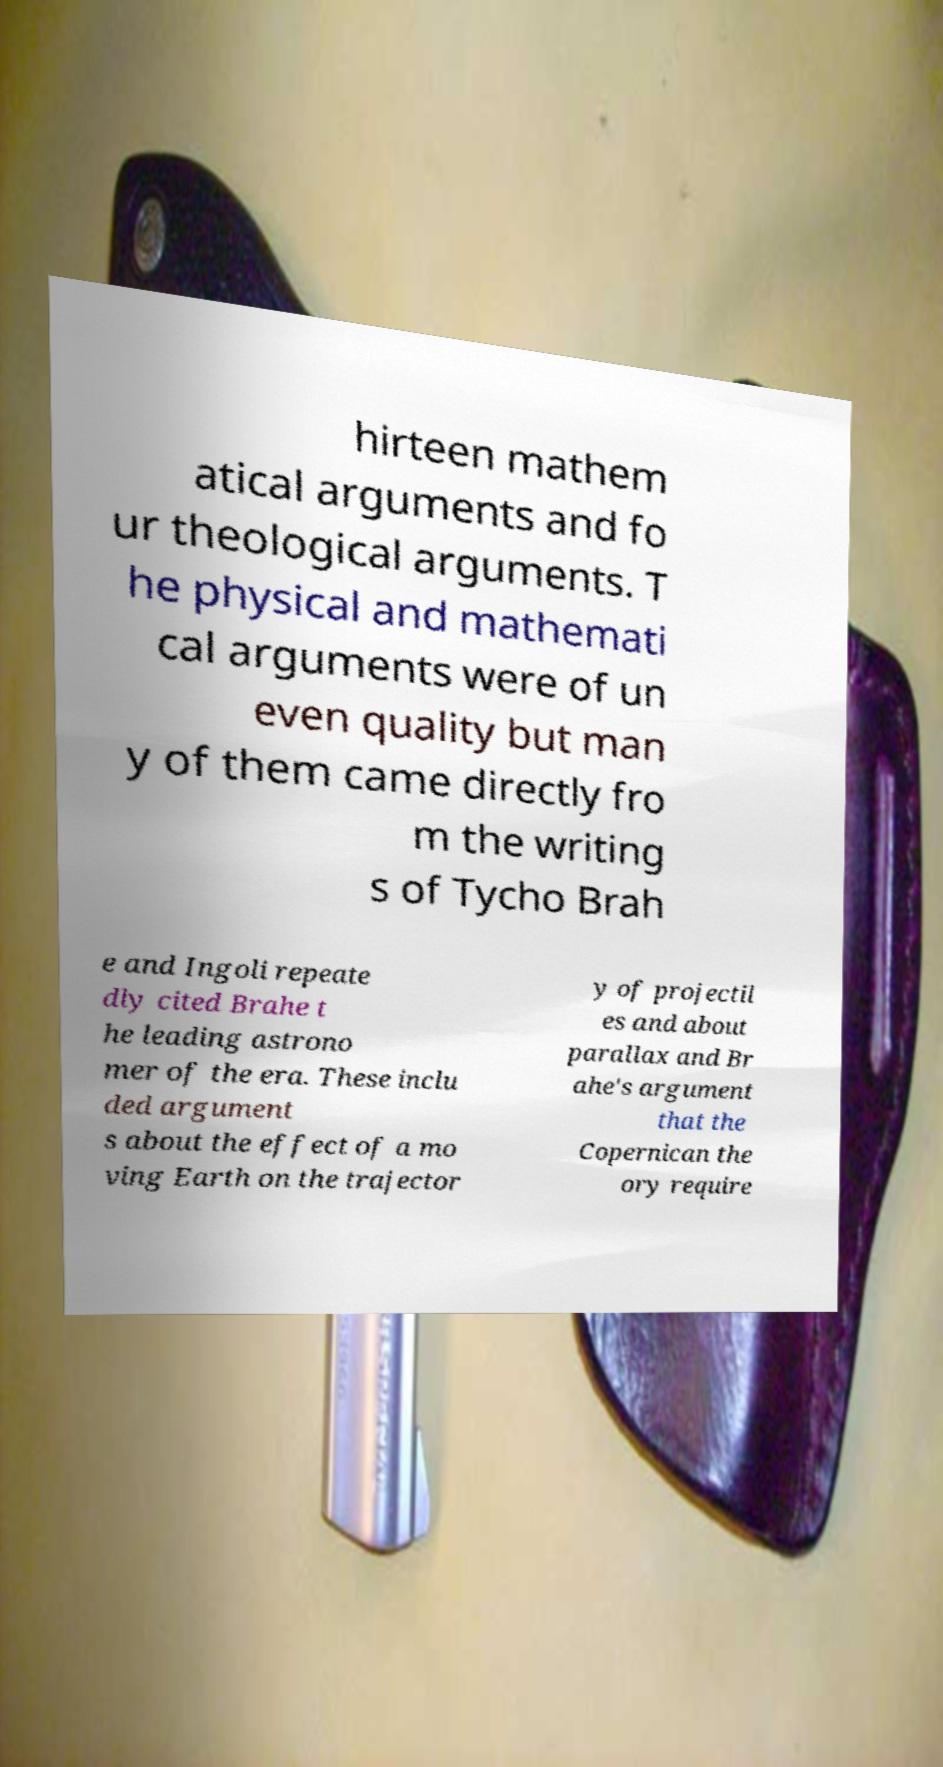What messages or text are displayed in this image? I need them in a readable, typed format. hirteen mathem atical arguments and fo ur theological arguments. T he physical and mathemati cal arguments were of un even quality but man y of them came directly fro m the writing s of Tycho Brah e and Ingoli repeate dly cited Brahe t he leading astrono mer of the era. These inclu ded argument s about the effect of a mo ving Earth on the trajector y of projectil es and about parallax and Br ahe's argument that the Copernican the ory require 